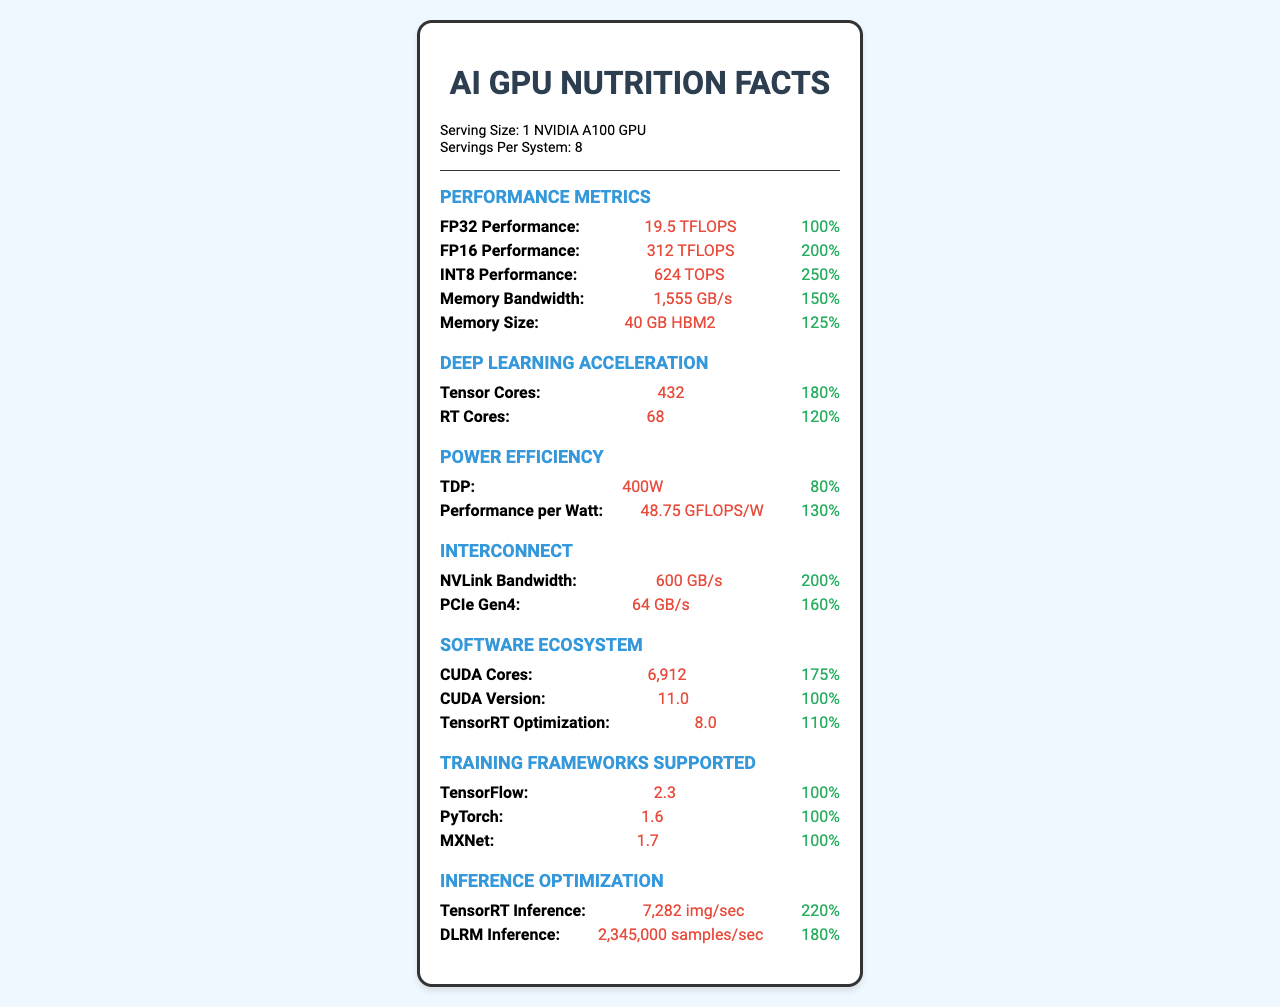What is the serving size? The document states the serving size is "1 NVIDIA A100 GPU".
Answer: 1 NVIDIA A100 GPU How much FP32 performance does one NVIDIA A100 GPU provide? The document lists the FP32 performance as "19.5 TFLOPS".
Answer: 19.5 TFLOPS What is the total number of Tensor Cores in the system? 432 Tensor Cores per GPU multiplied by 8 (servings per system). 432 * 8 = 3,456.
Answer: 3,456 What is the daily value percentage of INT8 Performance? The document states that the daily value for INT8 Performance is "250%".
Answer: 250% What is the TDP of the NVIDIA A100 GPU? The document lists the TDP as "400W".
Answer: 400W Which performance metric has the highest daily value percentage? The INT8 Performance has a daily value of "250%", which is the highest listed value.
Answer: INT8 Performance How much memory size does one GPU have? The document states the memory size is "40 GB HBM2".
Answer: 40 GB HBM2 How efficient is the NVIDIA A100 GPU in terms of performance per watt? The document lists the performance per watt as "48.75 GFLOPS/W".
Answer: 48.75 GFLOPS/W Which training frameworks are supported by the NVIDIA A100 GPU? 
A. TensorFlow
B. PyTorch
C. MXNet
D. All of the above The document lists TensorFlow (2.3), PyTorch (1.6), and MXNet (1.7) as supported training frameworks.
Answer: D What version of CUDA does the NVIDIA A100 GPU support? 
I. 9.2
II. 10.2
III. 11.0 The document states the CUDA version as "11.0".
Answer: III Does the document provide information on inference optimization performance? It mentions TensorRT Inference (7,282 img/sec) and DLRM Inference (2,345,000 samples/sec).
Answer: Yes Summarize the main idea of the document. The document essentially serves as a "Nutrition Facts" label for the NVIDIA A100 GPU, detailing various technical specifications and efficiencies relevant to deep learning and AI tasks.
Answer: The document provides detailed performance metrics and capabilities of the NVIDIA A100 GPU, including its computation power, memory size, deep learning acceleration, power efficiency, supported software ecosystem, and inference optimization. What is the NVLink Bandwidth per GPU in the NVIDIA A100 system? NVLink Bandwidth per system is 600 GB/s, and since there are 8 GPUs, 600 / 8 = 75 GB/s per GPU.
Answer: 75 GB/s Compare the memory bandwidth to the memory size in terms of daily value percentage. Which is higher? The Memory Bandwidth has a daily value of 150%, while Memory Size has 125%.
Answer: Memory Bandwidth Can the document tell you how many CUDA cores are present in a single GPU? It indicates that a single NVIDIA A100 GPU has 6,912 CUDA Cores.
Answer: Yes What is the DV for RT Cores in NVIDIA A100 GPU? A. 100% B. 200% C. 120% D. 80% The document lists the daily value for RT Cores as "120%".
Answer: C Which performance metric does the document indicate has the highest absolute value? The INT8 Performance is listed as 624 TOPS, which is the highest absolute value compared to other metrics listed.
Answer: INT8 Performance What kind of interconnect bandwidth does each GPU support in addition to NVLink? The document lists the PCIe Gen4 bandwidth as 64 GB/s.
Answer: PCIe Gen4 Is the information about the fabrication process technology (e.g., nm) mentioned in the document? The document does not mention anything about the fabrication process technology.
Answer: Cannot be determined Explain the deep learning acceleration metrics listed in the document. The Tensor Cores are specialized for deep learning and matrix operations, and the RT Cores are optimized for real-time ray tracing.
Answer: The document lists Tensor Cores (432) and RT Cores (68) as metrics under deep learning acceleration. These metrics are specific hardware components that enhance the GPU's capabilities for AI and deep learning tasks. 